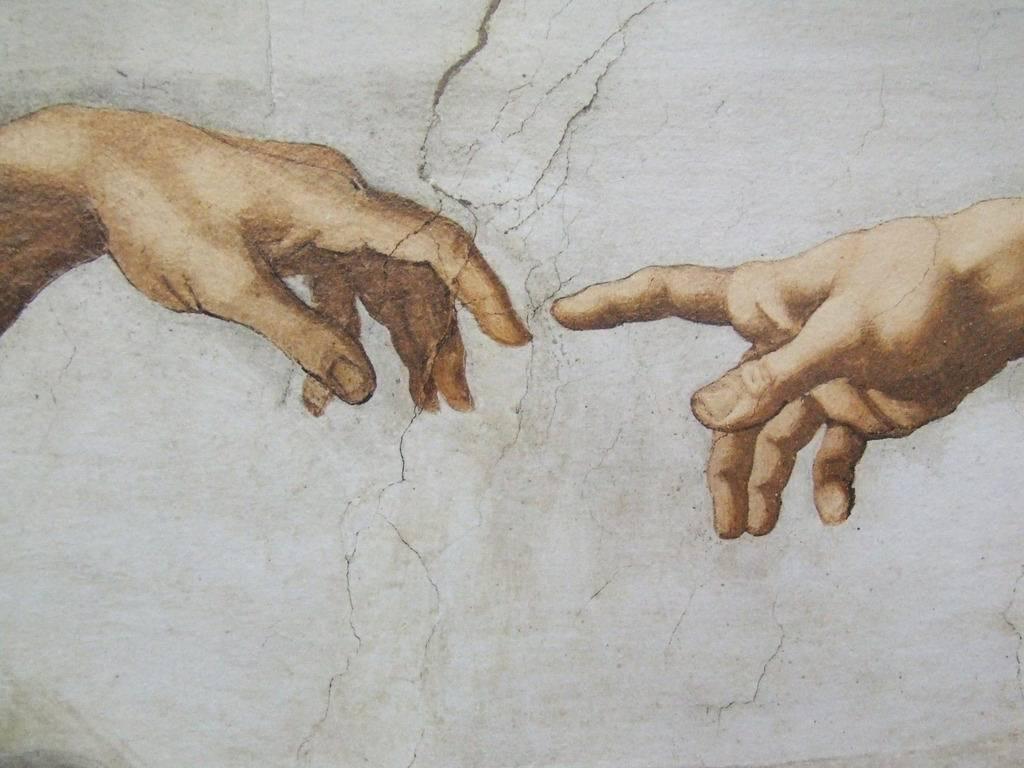Can you describe this image briefly? In the image we can see a painting of a person's hand on the wall. There are a few cracks on the wall. 